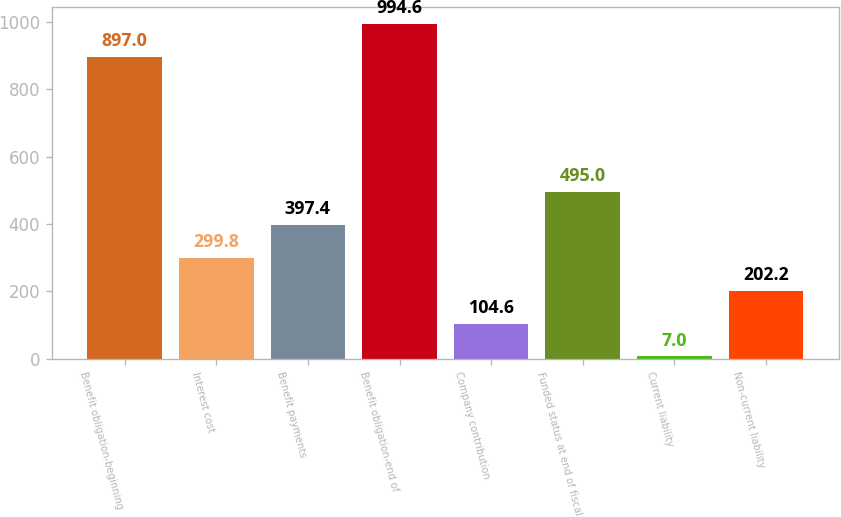Convert chart. <chart><loc_0><loc_0><loc_500><loc_500><bar_chart><fcel>Benefit obligation-beginning<fcel>Interest cost<fcel>Benefit payments<fcel>Benefit obligation-end of<fcel>Company contribution<fcel>Funded status at end of fiscal<fcel>Current liability<fcel>Non-current liability<nl><fcel>897<fcel>299.8<fcel>397.4<fcel>994.6<fcel>104.6<fcel>495<fcel>7<fcel>202.2<nl></chart> 